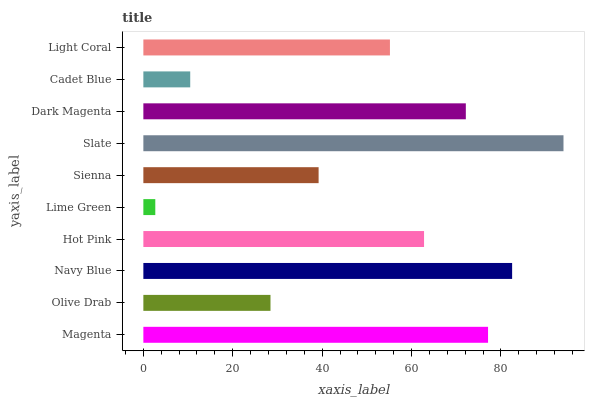Is Lime Green the minimum?
Answer yes or no. Yes. Is Slate the maximum?
Answer yes or no. Yes. Is Olive Drab the minimum?
Answer yes or no. No. Is Olive Drab the maximum?
Answer yes or no. No. Is Magenta greater than Olive Drab?
Answer yes or no. Yes. Is Olive Drab less than Magenta?
Answer yes or no. Yes. Is Olive Drab greater than Magenta?
Answer yes or no. No. Is Magenta less than Olive Drab?
Answer yes or no. No. Is Hot Pink the high median?
Answer yes or no. Yes. Is Light Coral the low median?
Answer yes or no. Yes. Is Magenta the high median?
Answer yes or no. No. Is Olive Drab the low median?
Answer yes or no. No. 